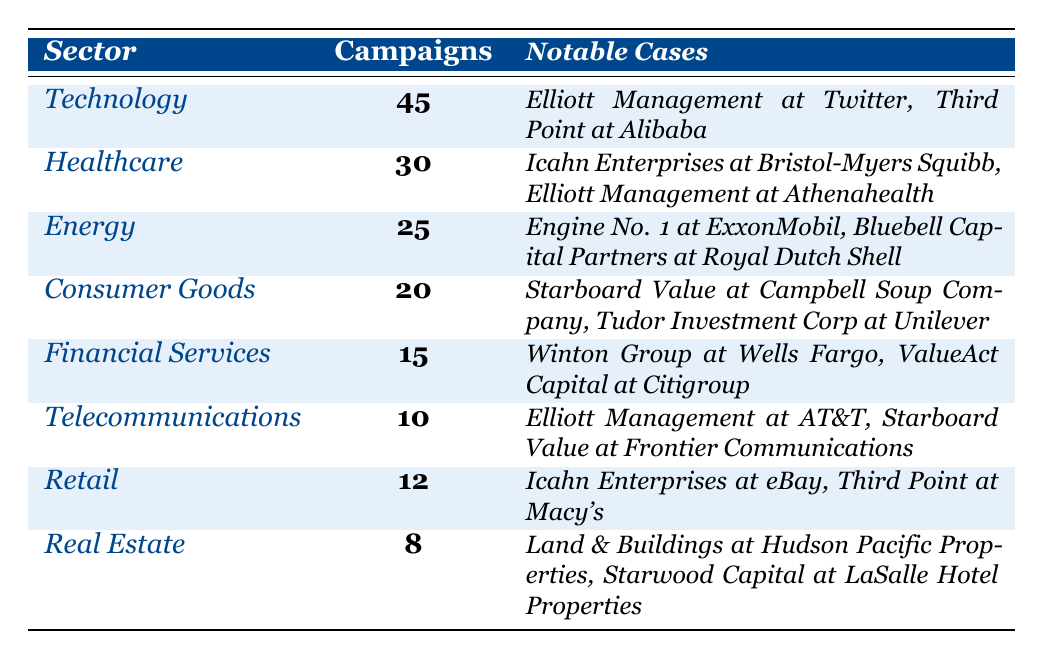What sector had the most shareholder activism campaigns? The table shows that the Technology sector has the highest number of campaigns, with a total of 45.
Answer: Technology How many notable cases did Elliott Management engage in? Elliott Management is mentioned in three notable cases across the Technology, Healthcare, and Telecommunications sectors.
Answer: 3 What is the total number of campaigns in the Consumer Goods and Retail sectors combined? The Consumer Goods sector had 20 campaigns, and the Retail sector had 12 campaigns; adding these values gives a total of 20 + 12 = 32.
Answer: 32 Did the Financial Services sector have more or fewer campaigns than the Real Estate sector? Financial Services had 15 campaigns, while Real Estate had 8 campaigns, meaning Financial Services had more.
Answer: More What is the average number of campaigns across all sectors listed in the table? We sum all the campaigns: 45 + 30 + 25 + 20 + 15 + 10 + 12 + 8 = 165. There are 8 sectors, so the average is 165 / 8 = 20.625.
Answer: 20.625 Which sector has the highest number of notable cases mentioned? The Technology sector has two notable cases, just like the Healthcare and Energy sectors; all three sectors tie for the highest number mentioned.
Answer: Tie (Technology, Healthcare, Energy) What is the difference in the number of campaigns between the Energy and Telecommunications sectors? The Energy sector has 25 campaigns, while Telecommunications has 10; the difference is 25 - 10 = 15.
Answer: 15 Has Icahn Enterprises been involved in more campaigns than Bluebell Capital Partners? Icahn Enterprises is involved in 2 campaigns (both in Healthcare and Retail), while Bluebell Capital Partners is involved in 1 campaign (in Energy); thus, Icahn Enterprises has been involved in more.
Answer: Yes What is the total number of campaigns in the sectors considered above the Retail sector? The sectors above Retail in the table are Technology, Healthcare, Energy, and Consumer Goods, with campaigns of 45, 30, 25, and 20 respectively. Adding these gives 45 + 30 + 25 + 20 = 120.
Answer: 120 Which sector has the least number of campaigns and how many did it have? The Real Estate sector has the least number of campaigns, with only 8 recorded.
Answer: Real Estate, 8 